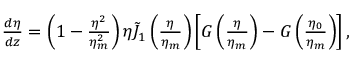Convert formula to latex. <formula><loc_0><loc_0><loc_500><loc_500>\begin{array} { r l r } & { \, \frac { d \eta } { d z } = \left ( 1 - \frac { \eta ^ { 2 } } { \eta _ { m } ^ { 2 } } \right ) \eta \tilde { J } _ { 1 } \left ( \frac { \eta } { \eta _ { m } } \right ) \left [ G \left ( \frac { \eta } { \eta _ { m } } \right ) - G \left ( \frac { \eta _ { 0 } } { \eta _ { m } } \right ) \right ] , } \end{array}</formula> 